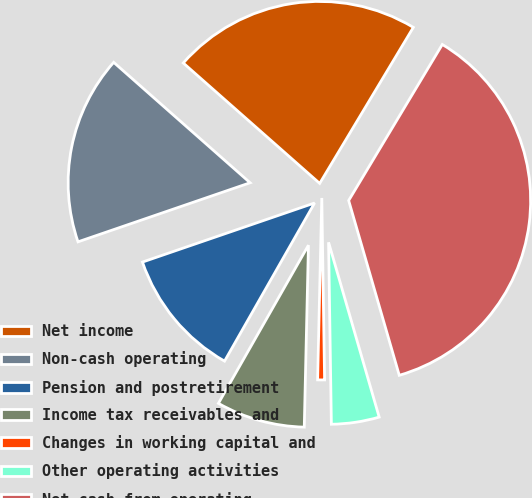Convert chart to OTSL. <chart><loc_0><loc_0><loc_500><loc_500><pie_chart><fcel>Net income<fcel>Non-cash operating<fcel>Pension and postretirement<fcel>Income tax receivables and<fcel>Changes in working capital and<fcel>Other operating activities<fcel>Net cash from operating<nl><fcel>22.09%<fcel>16.77%<fcel>11.5%<fcel>7.87%<fcel>0.61%<fcel>4.24%<fcel>36.91%<nl></chart> 